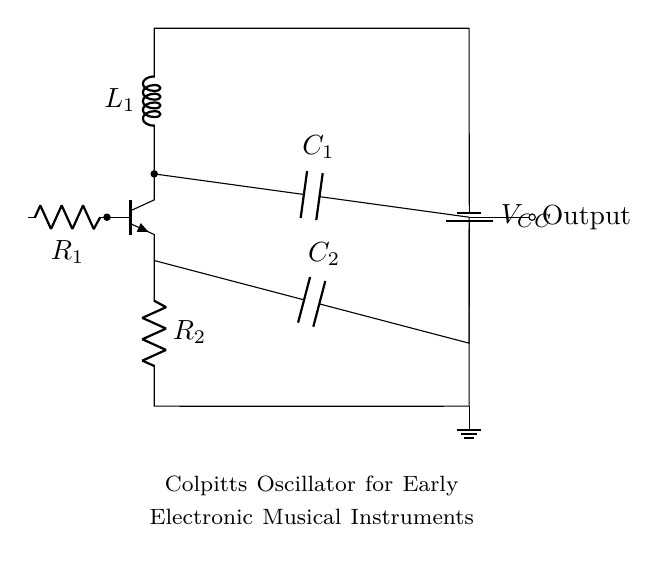What type of transistor is used? The circuit uses an NPN transistor, indicated by the notation "npn" on the Q node in the diagram.
Answer: NPN What is the value of the capacitor labeled C1? The circuit does not specify a numeric value for C1, only referring to it by its label. However, it can be inferred that it’s part of the Colpitts oscillator configuration impacting frequency.
Answer: C1 How many resistors are present in the circuit? There are two resistors in the circuit, labeled R1 and R2, which can be clearly seen in the diagram.
Answer: 2 What is the function of C2 in the circuit? Capacitor C2 is used for coupling in the circuit, typically affecting signal stability and frequency characteristics in oscillators.
Answer: Coupling What component provides the output signal? The output is taken from the junction where C1 connects, denoted as "Output," which indicates it is the point from which the oscillating signal is derived.
Answer: Output What is the purpose of R1 and R2 in the circuit? Both R1 and R2 function as biasing resistors for the transistor, essential for setting the operating point and stabilizing the oscillator's performance.
Answer: Biasing 